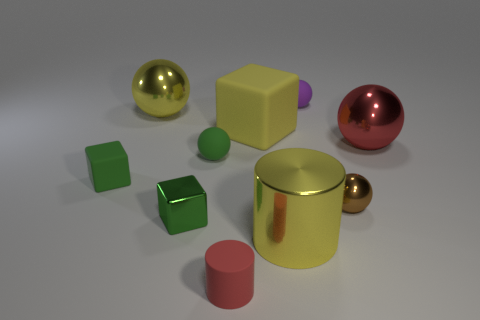Subtract all matte spheres. How many spheres are left? 3 Subtract all blue spheres. How many green blocks are left? 2 Subtract all red cylinders. How many cylinders are left? 1 Subtract 1 blocks. How many blocks are left? 2 Subtract all cylinders. How many objects are left? 8 Add 9 yellow matte cubes. How many yellow matte cubes are left? 10 Add 6 large metal spheres. How many large metal spheres exist? 8 Subtract 1 purple balls. How many objects are left? 9 Subtract all red cylinders. Subtract all cyan cubes. How many cylinders are left? 1 Subtract all green rubber things. Subtract all large red metal cylinders. How many objects are left? 8 